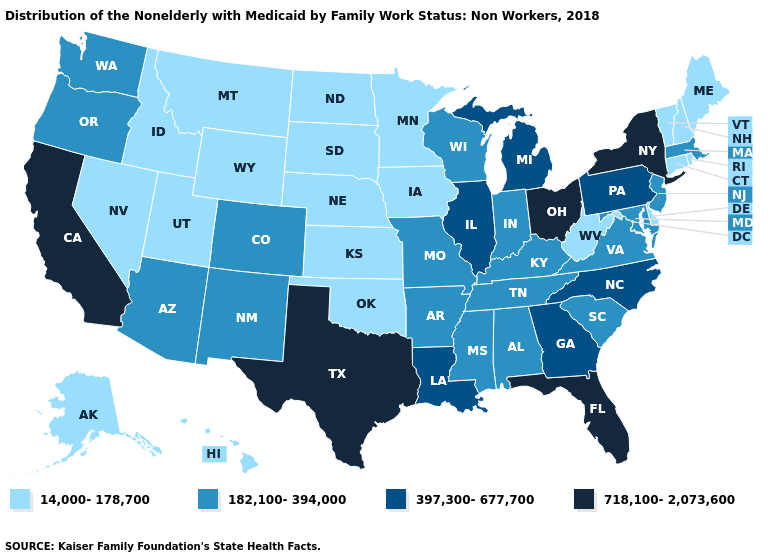What is the lowest value in the Northeast?
Answer briefly. 14,000-178,700. What is the value of Colorado?
Quick response, please. 182,100-394,000. Which states hav the highest value in the MidWest?
Quick response, please. Ohio. Which states have the highest value in the USA?
Quick response, please. California, Florida, New York, Ohio, Texas. What is the lowest value in states that border Virginia?
Concise answer only. 14,000-178,700. What is the highest value in the USA?
Quick response, please. 718,100-2,073,600. Does Ohio have the highest value in the MidWest?
Answer briefly. Yes. Among the states that border Massachusetts , does Connecticut have the highest value?
Short answer required. No. What is the lowest value in the MidWest?
Concise answer only. 14,000-178,700. What is the lowest value in the West?
Short answer required. 14,000-178,700. Does Texas have the highest value in the USA?
Concise answer only. Yes. Is the legend a continuous bar?
Give a very brief answer. No. What is the value of Iowa?
Keep it brief. 14,000-178,700. Is the legend a continuous bar?
Give a very brief answer. No. Name the states that have a value in the range 718,100-2,073,600?
Keep it brief. California, Florida, New York, Ohio, Texas. 